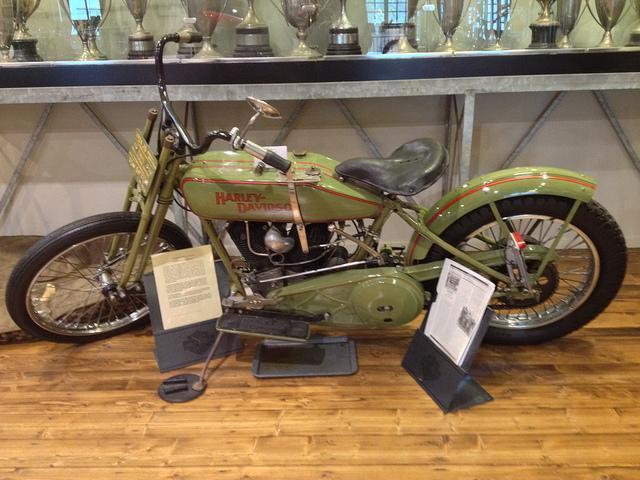How many rolls of toilet paper are in the photo?
Give a very brief answer. 0. 